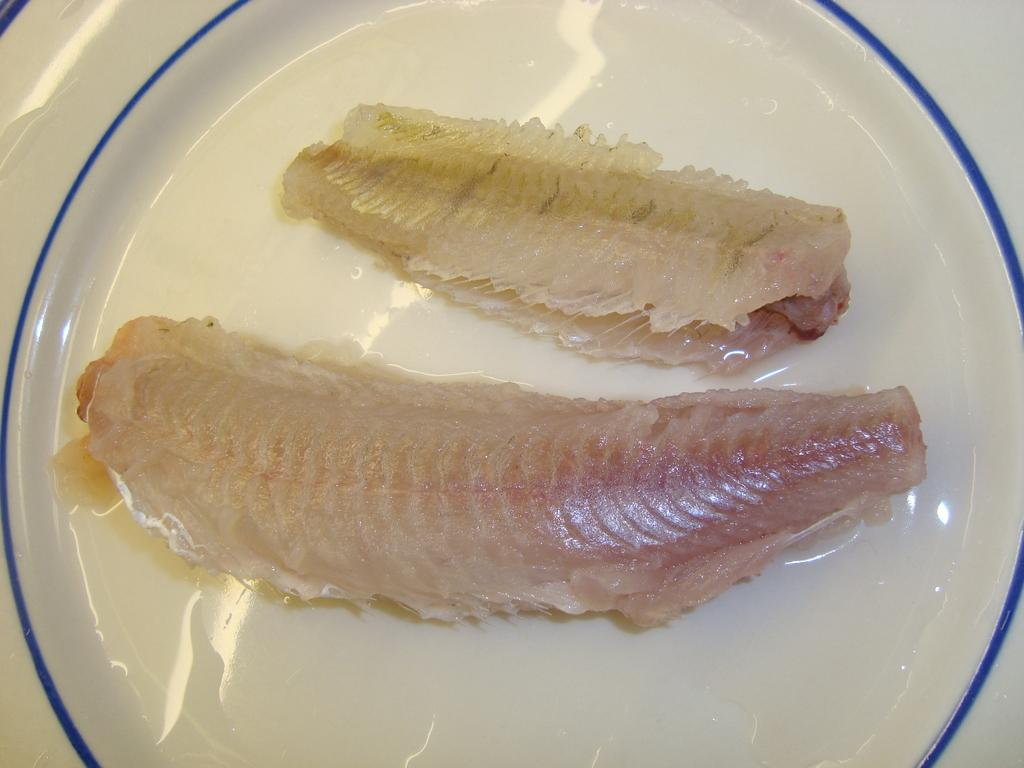What is present on the plate in the image? There is meat on the plate in the image. What is the color of the plate? The plate is white in color. What type of oatmeal can be seen on the plate in the image? There is no oatmeal present on the plate in the image; it contains meat. How does the meat on the plate affect the smash in the image? There is no smash present in the image, so it cannot be affected by the meat on the plate. 